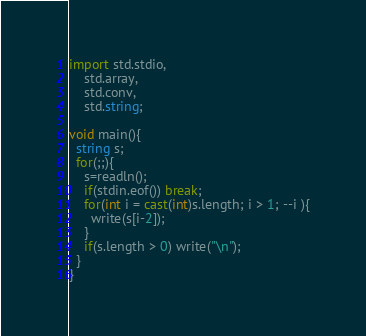<code> <loc_0><loc_0><loc_500><loc_500><_D_>import std.stdio,
    std.array,
    std.conv,
    std.string;

void main(){
  string s;
  for(;;){
    s=readln();
    if(stdin.eof()) break;
    for(int i = cast(int)s.length; i > 1; --i ){
      write(s[i-2]);
    }
    if(s.length > 0) write("\n");
  }
}</code> 